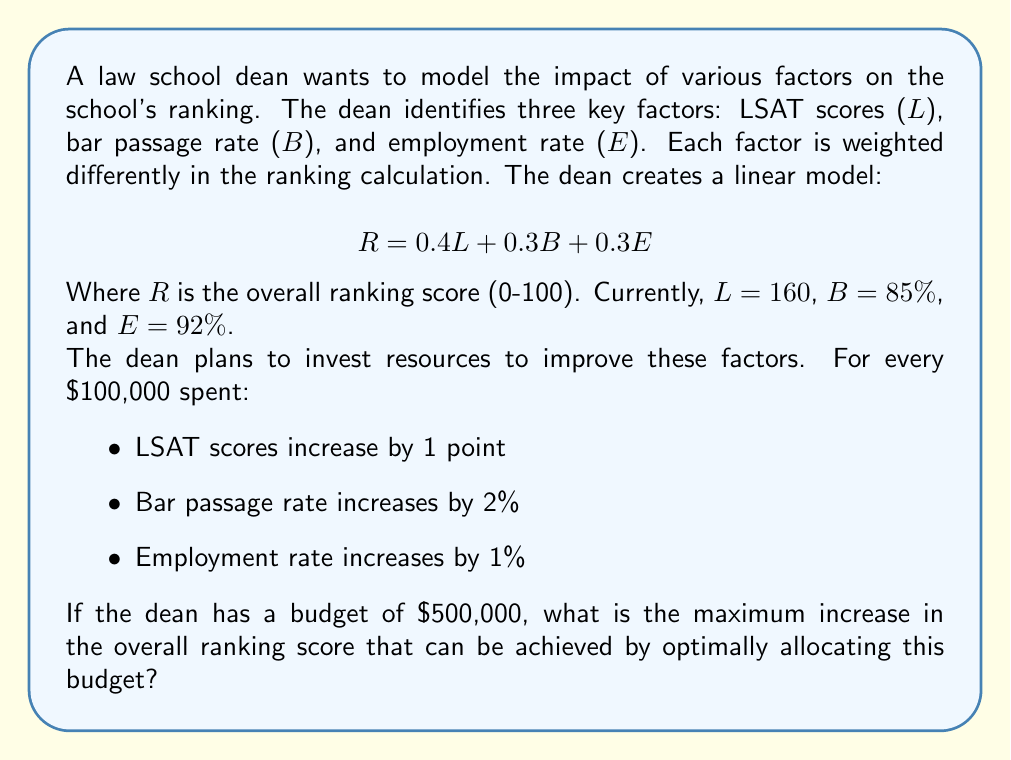Teach me how to tackle this problem. Let's approach this step-by-step:

1) First, we need to calculate the current ranking score:
   $R_{current} = 0.4(160) + 0.3(85) + 0.3(92) = 64 + 25.5 + 27.6 = 117.1$

2) Now, let's consider the impact of each $100,000 investment:
   - LSAT: $0.4 * 1 = 0.4$ points increase in R
   - Bar passage: $0.3 * 2 = 0.6$ points increase in R
   - Employment: $0.3 * 1 = 0.3$ points increase in R

3) Clearly, investing in bar passage rate gives the highest return per $100,000.

4) With a budget of $500,000, we can make 5 investments of $100,000 each.

5) The optimal strategy is to invest all $500,000 in improving the bar passage rate.

6) This will result in a total increase of:
   $5 * 0.6 = 3$ points in the ranking score

7) The new bar passage rate will be:
   $85\% + (5 * 2\%) = 95\%$

8) The new ranking score will be:
   $R_{new} = 0.4(160) + 0.3(95) + 0.3(92) = 64 + 28.5 + 27.6 = 120.1$

9) The increase in ranking score is:
   $120.1 - 117.1 = 3$ points
Answer: 3 points 